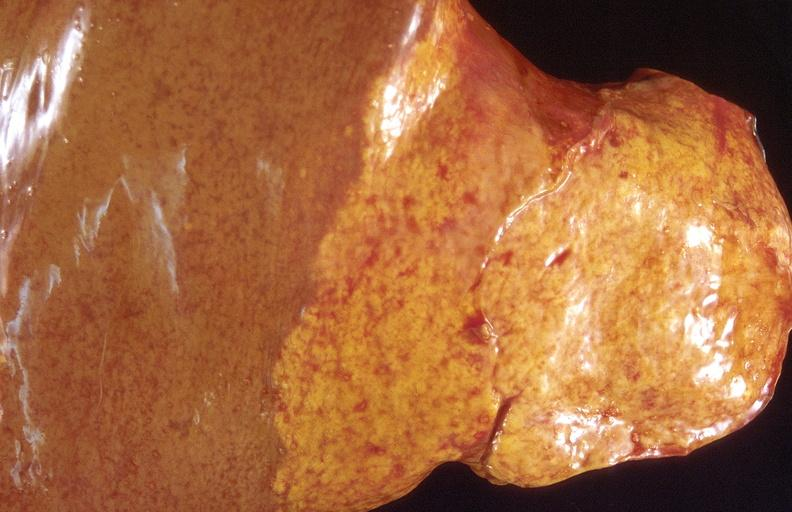does this image show cholangiocarcinoma?
Answer the question using a single word or phrase. Yes 